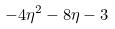Convert formula to latex. <formula><loc_0><loc_0><loc_500><loc_500>- 4 \eta ^ { 2 } - 8 \eta - 3</formula> 